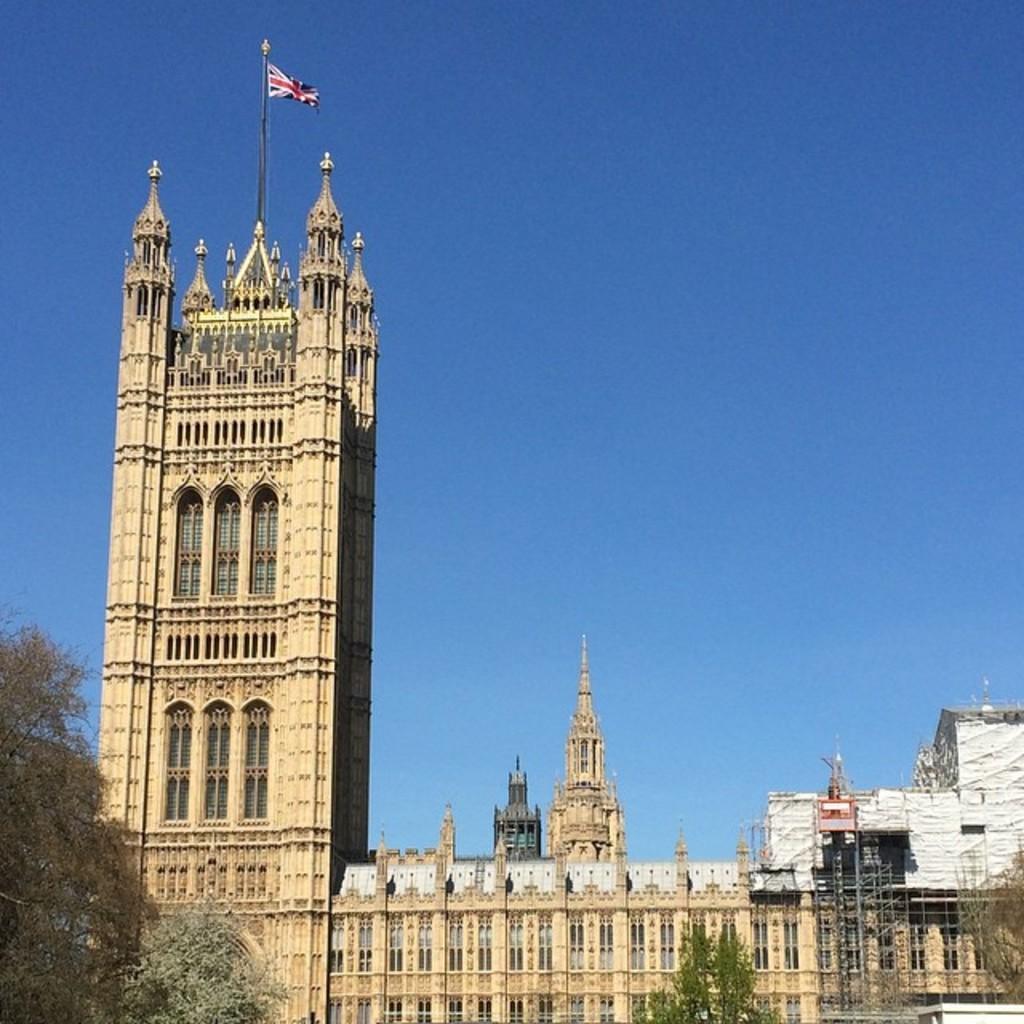Describe this image in one or two sentences. In this image, we can see buildings, rods, walls, windows and trees. In the background, there is the sky. On top of the building, we can see a pole with flag. 